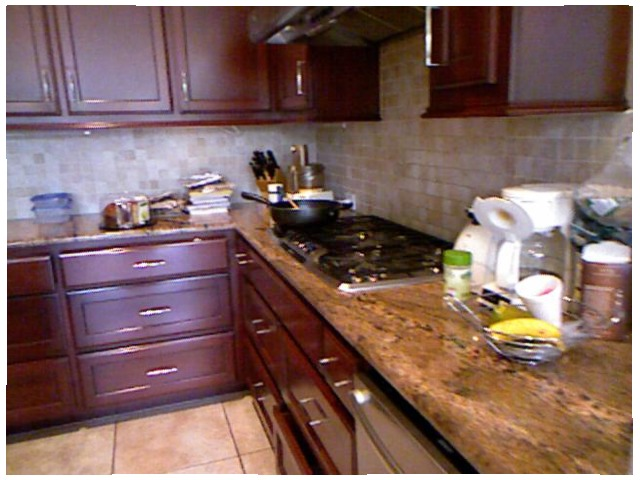<image>
Is the plastic cup behind the gas stow? No. The plastic cup is not behind the gas stow. From this viewpoint, the plastic cup appears to be positioned elsewhere in the scene. 